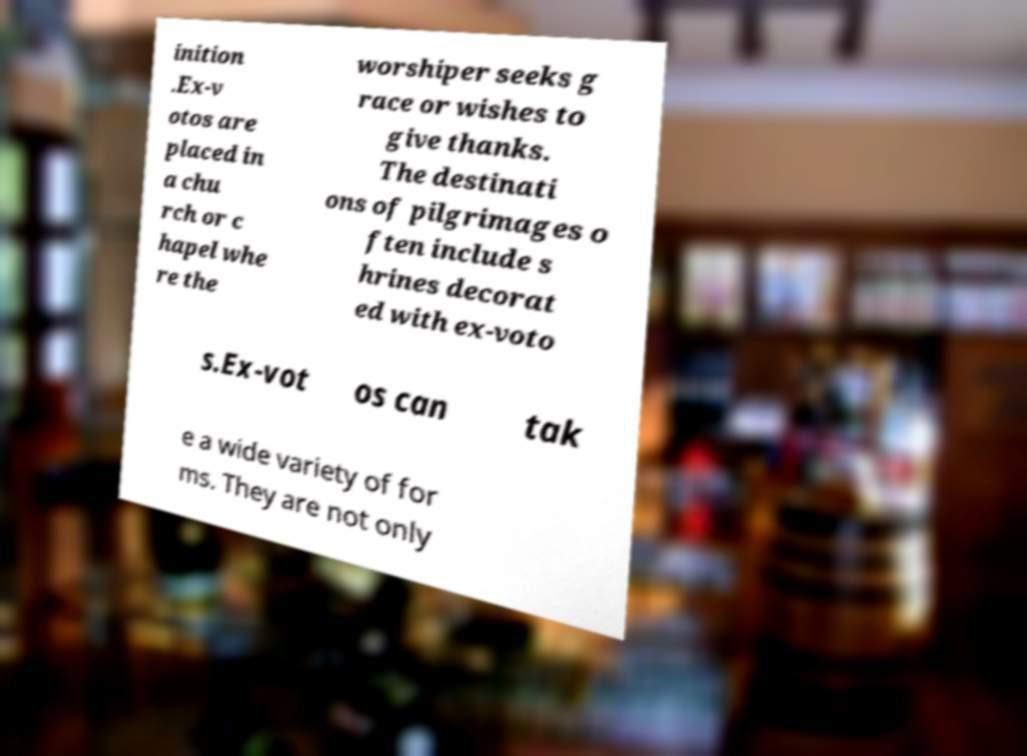Please read and relay the text visible in this image. What does it say? inition .Ex-v otos are placed in a chu rch or c hapel whe re the worshiper seeks g race or wishes to give thanks. The destinati ons of pilgrimages o ften include s hrines decorat ed with ex-voto s.Ex-vot os can tak e a wide variety of for ms. They are not only 